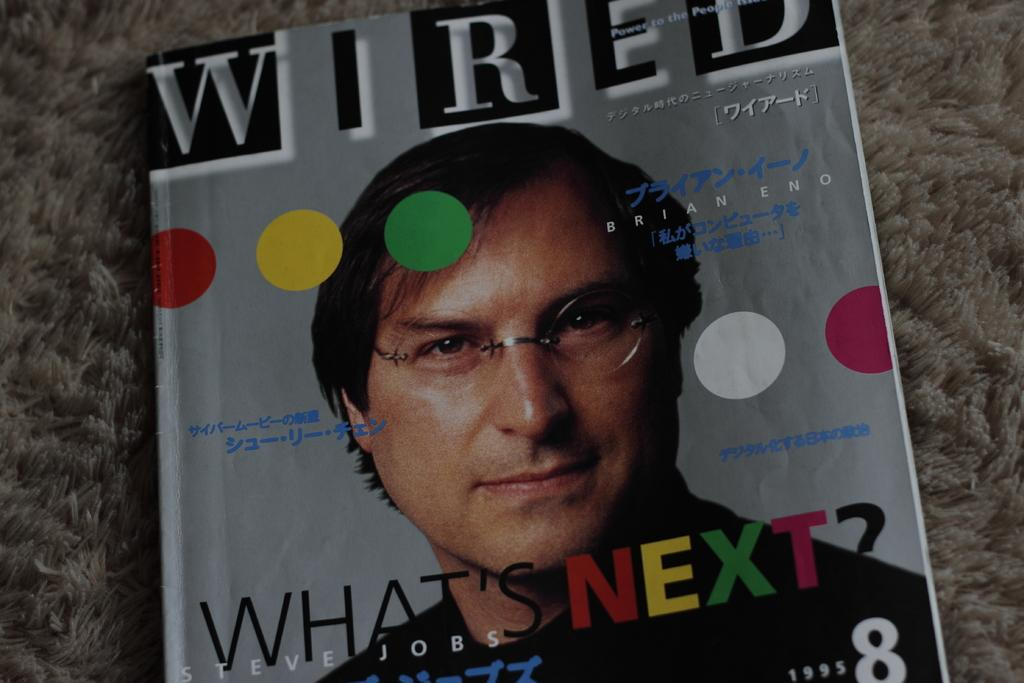What can be seen in the image related to reading material? There is a magazine in the image. Who is present in the image? There is a person in the image. What is written on the magazine? There is text printed on the magazine. What else is visible in the image? There is a cloth in the image. What type of business is the person conducting in the image? There is no indication of a business in the image; it only shows a person with a magazine and a cloth. What scientific discoveries are mentioned in the text on the magazine? There is no mention of scientific discoveries in the text on the magazine; the provided facts only mention that there is text printed on it. 